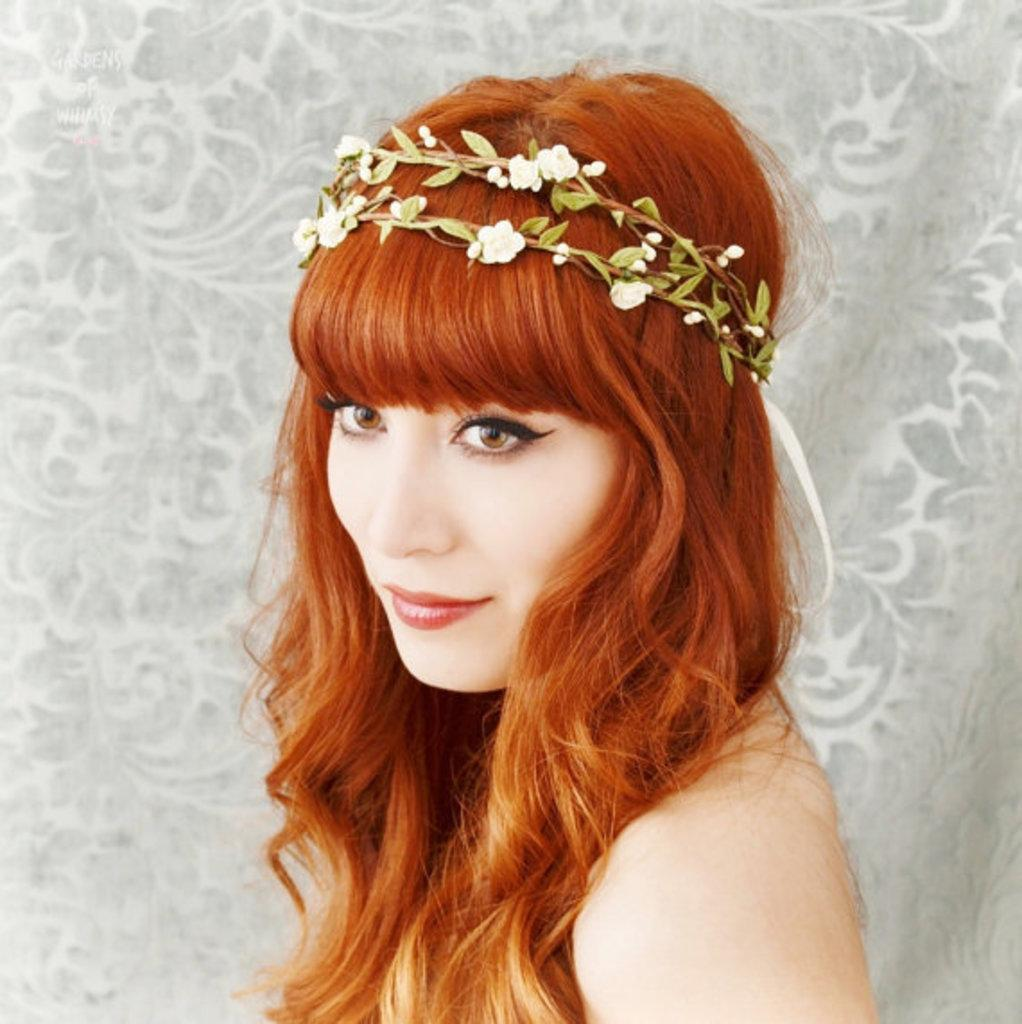Who is the main subject in the image? There is a lady in the center of the image. How many cattle are present in the image? There is no mention of cattle in the image, so it is not possible to determine their presence or quantity. 